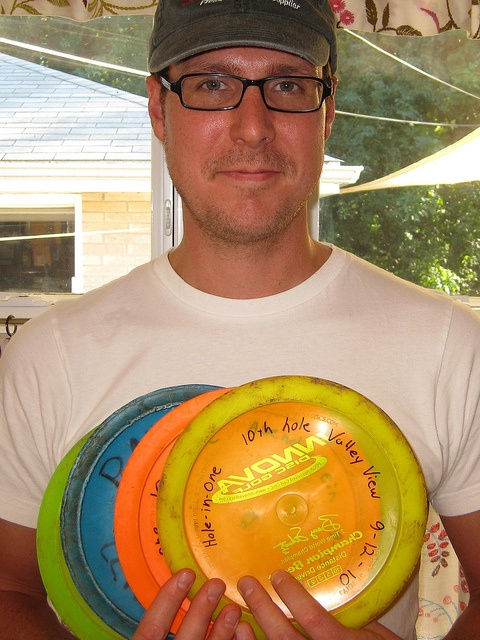Describe the objects in this image and their specific colors. I can see people in tan, orange, and brown tones, frisbee in tan, orange, olive, and gold tones, frisbee in tan, teal, gray, and black tones, frisbee in tan, red, orange, and brown tones, and frisbee in tan, olive, and gray tones in this image. 